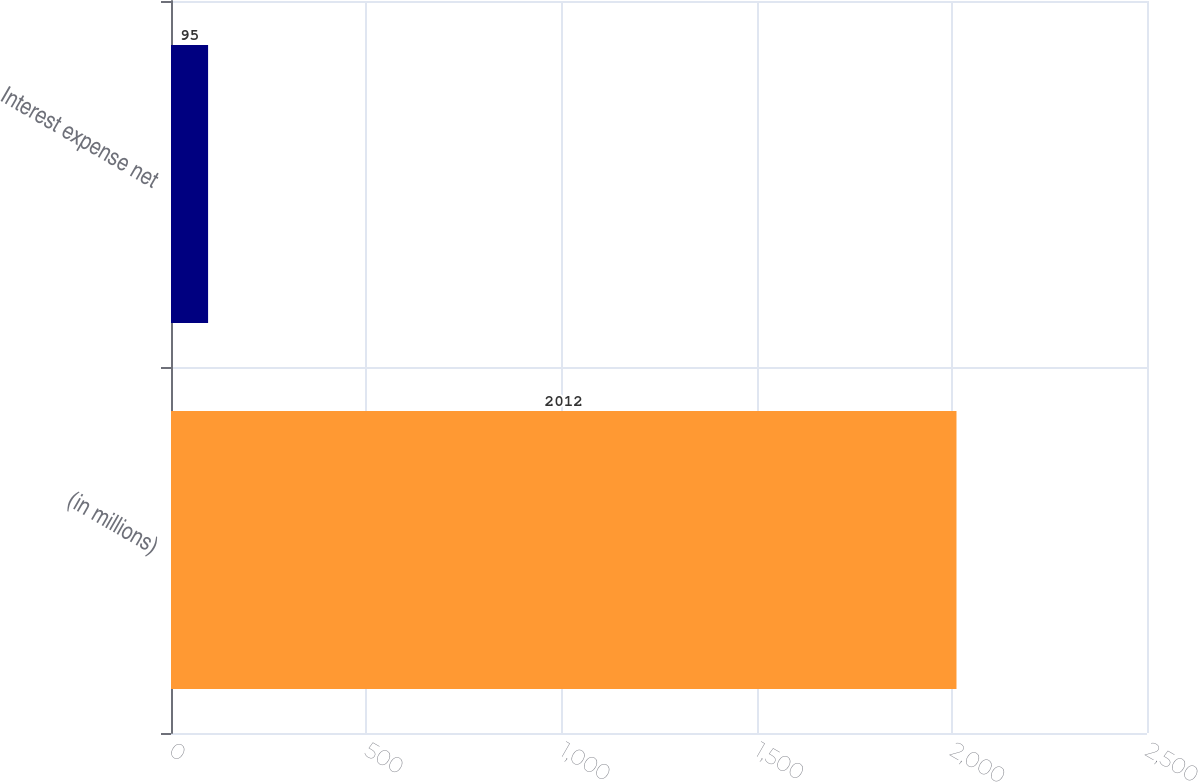Convert chart. <chart><loc_0><loc_0><loc_500><loc_500><bar_chart><fcel>(in millions)<fcel>Interest expense net<nl><fcel>2012<fcel>95<nl></chart> 